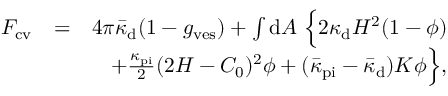Convert formula to latex. <formula><loc_0><loc_0><loc_500><loc_500>\begin{array} { r l r } { F _ { c v } } & { = } & { 4 \pi \bar { \kappa } _ { d } ( 1 - g _ { v e s } ) + \int { d } A \ \left \{ 2 \kappa _ { d } H ^ { 2 } ( 1 - \phi ) } \\ & { + \frac { \kappa _ { p i } } { 2 } ( 2 H - C _ { 0 } ) ^ { 2 } \phi + ( \bar { \kappa } _ { p i } - \bar { \kappa } _ { d } ) K \phi \right \} , } \end{array}</formula> 